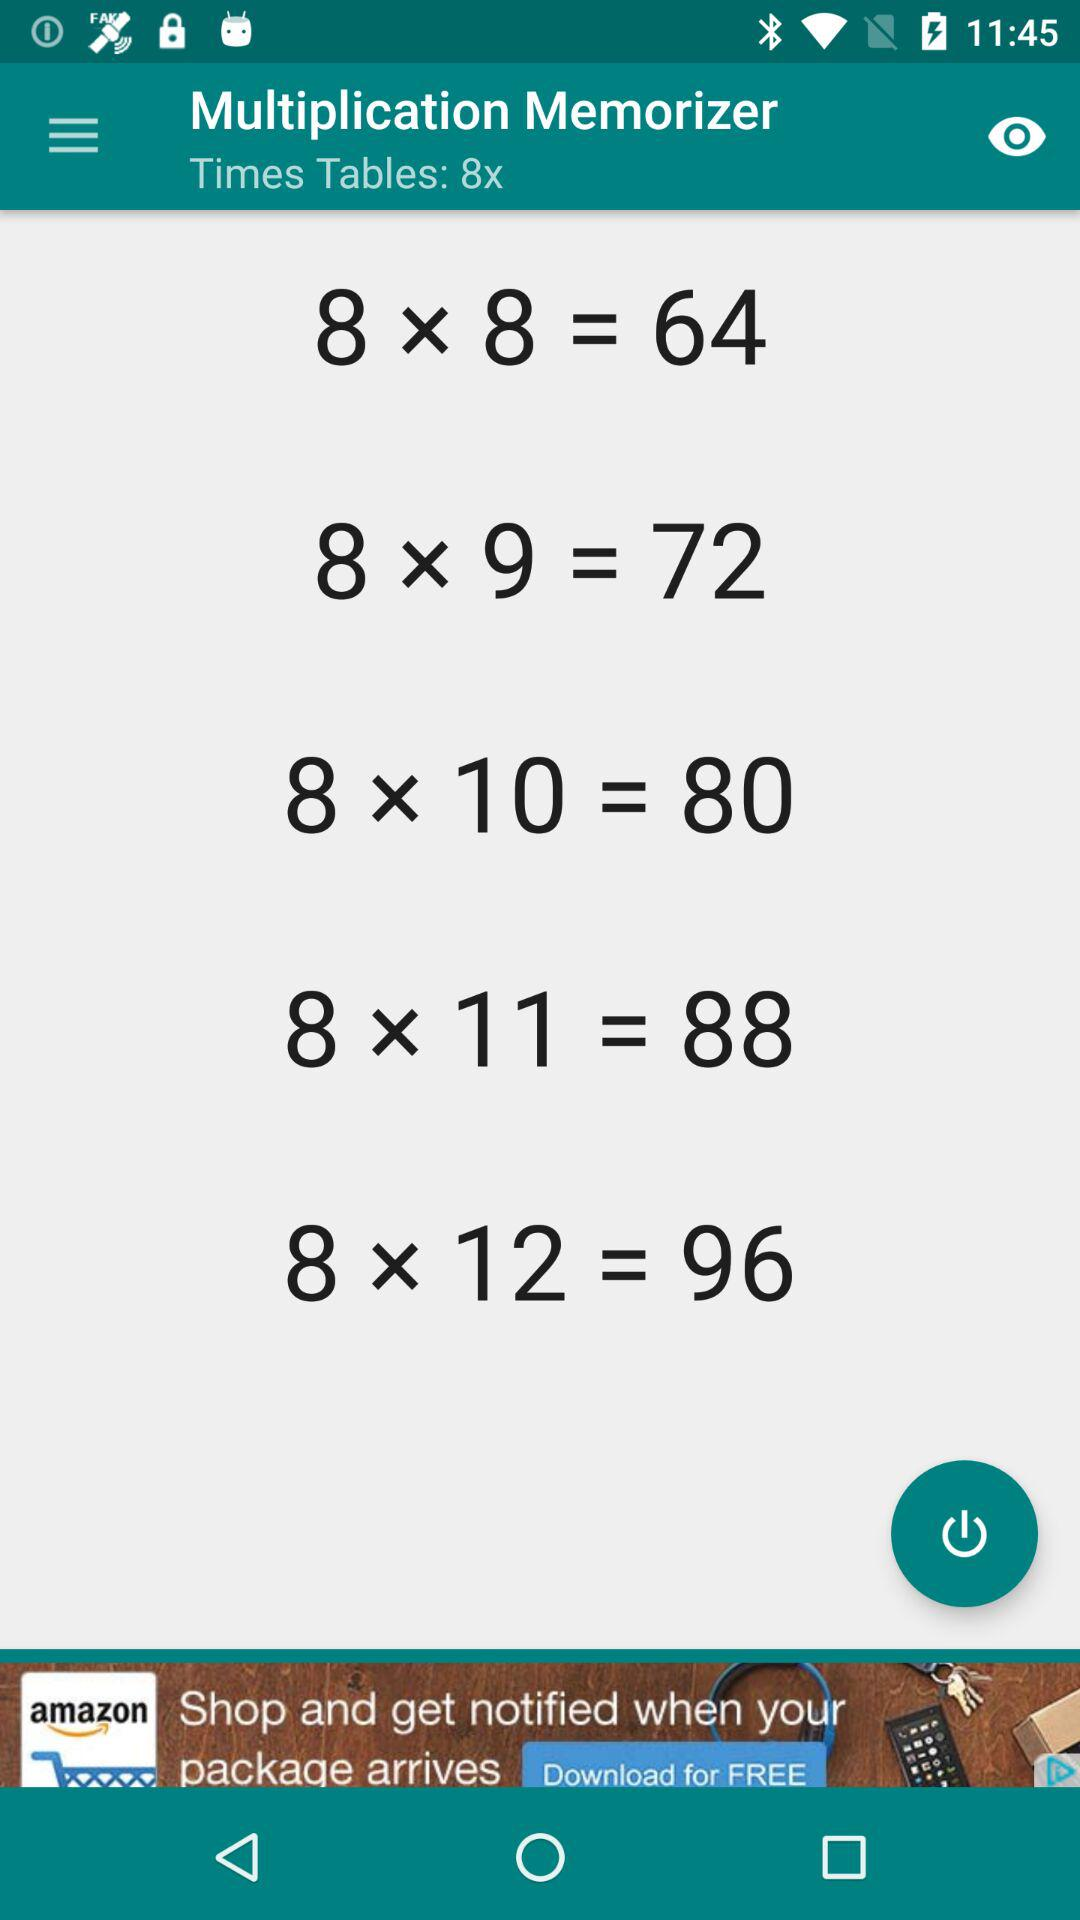Which table is shown on the screen? On the screen, the 8 times table is shown. 